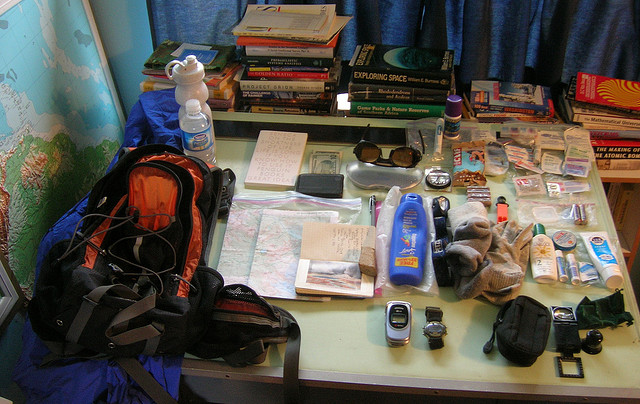What does this collection of items suggest about the destination? The presence of a map, guidebooks, sunscreen, and a camera hints at an outdoor travel destination, possibly involving hiking or exploring nature. The inclusion of insect repellent further suggests a destination where one might encounter insects, likely in a wilderness area or a place with a warm climate. 